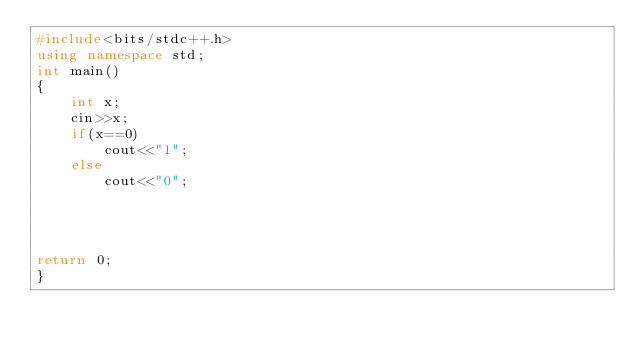<code> <loc_0><loc_0><loc_500><loc_500><_C++_>#include<bits/stdc++.h>
using namespace std;
int main()
{
    int x;
    cin>>x;
    if(x==0)
        cout<<"1";
    else
        cout<<"0";




return 0;
}

</code> 